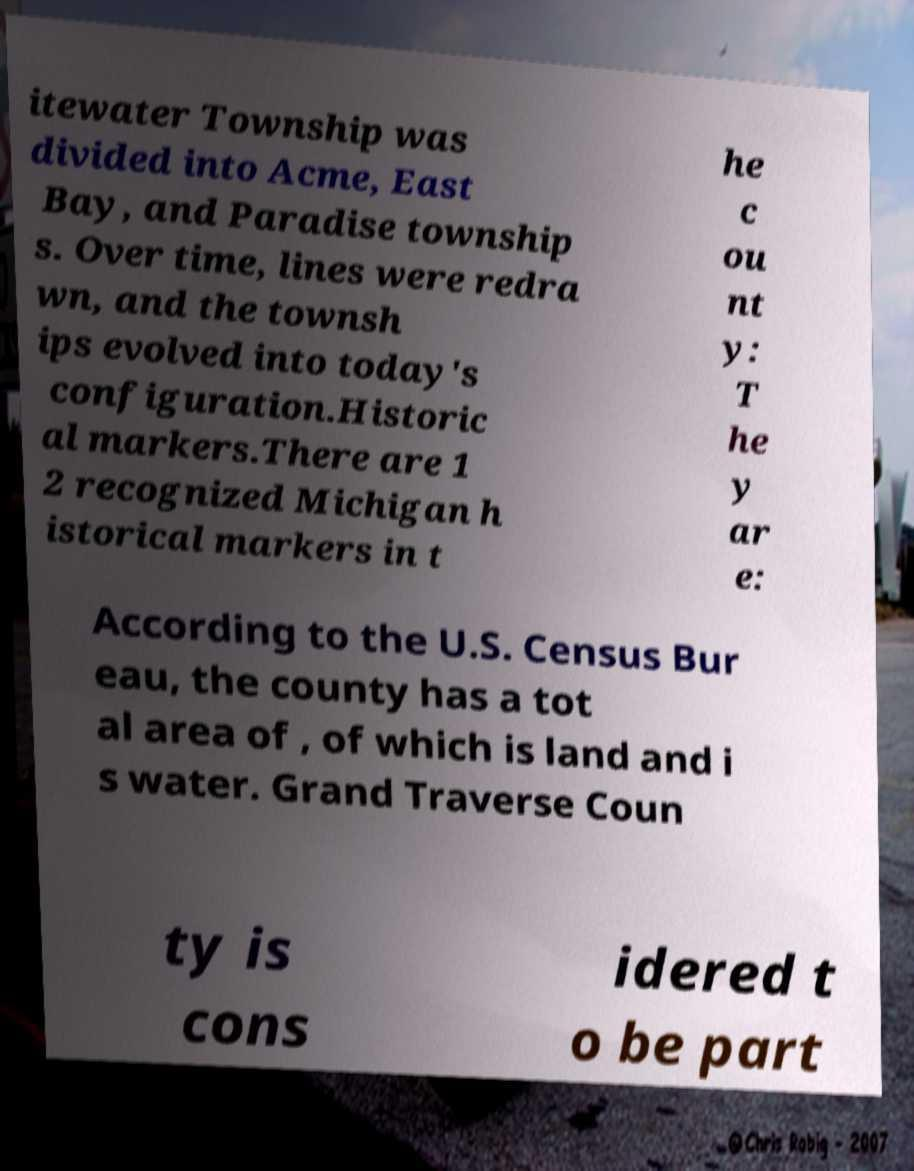I need the written content from this picture converted into text. Can you do that? itewater Township was divided into Acme, East Bay, and Paradise township s. Over time, lines were redra wn, and the townsh ips evolved into today's configuration.Historic al markers.There are 1 2 recognized Michigan h istorical markers in t he c ou nt y: T he y ar e: According to the U.S. Census Bur eau, the county has a tot al area of , of which is land and i s water. Grand Traverse Coun ty is cons idered t o be part 